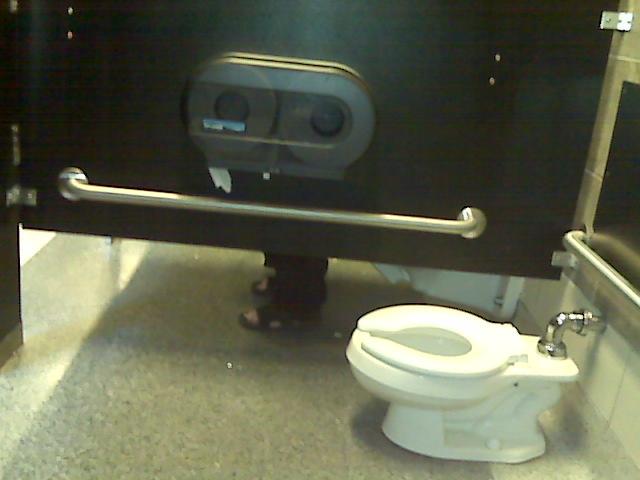Why is there a bar attached to the wall near the toilet?
Short answer required. To hold. What color is the dividing wall?
Answer briefly. Black. How many rolls of toilet paper?
Short answer required. 2. 